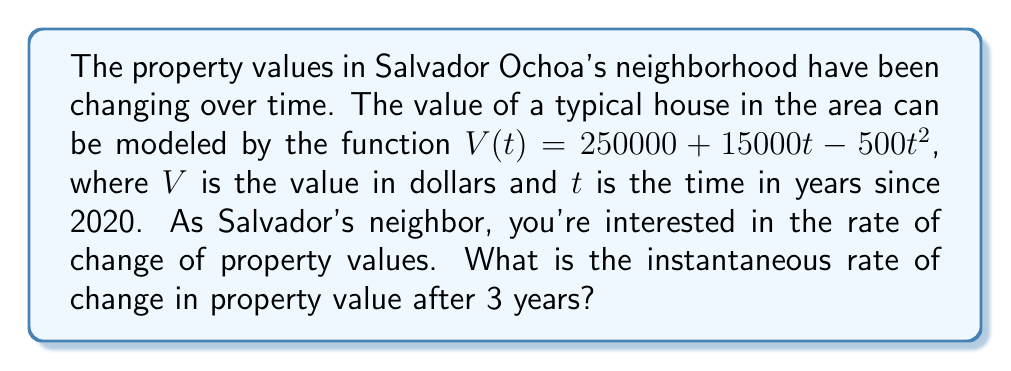What is the answer to this math problem? To find the instantaneous rate of change, we need to calculate the derivative of the given function and then evaluate it at $t = 3$.

Step 1: Find the derivative of $V(t)$.
$$V(t) = 250000 + 15000t - 500t^2$$
$$V'(t) = 15000 - 1000t$$

Step 2: Evaluate the derivative at $t = 3$.
$$V'(3) = 15000 - 1000(3)$$
$$V'(3) = 15000 - 3000$$
$$V'(3) = 12000$$

The instantaneous rate of change after 3 years is $12000 dollars per year.

Step 3: Interpret the result.
This positive value indicates that property values are still increasing after 3 years, but at a slower rate than initially. The rate of increase is declining by $1000 per year due to the negative coefficient of $t^2$ in the original function.
Answer: $12000 dollars per year 